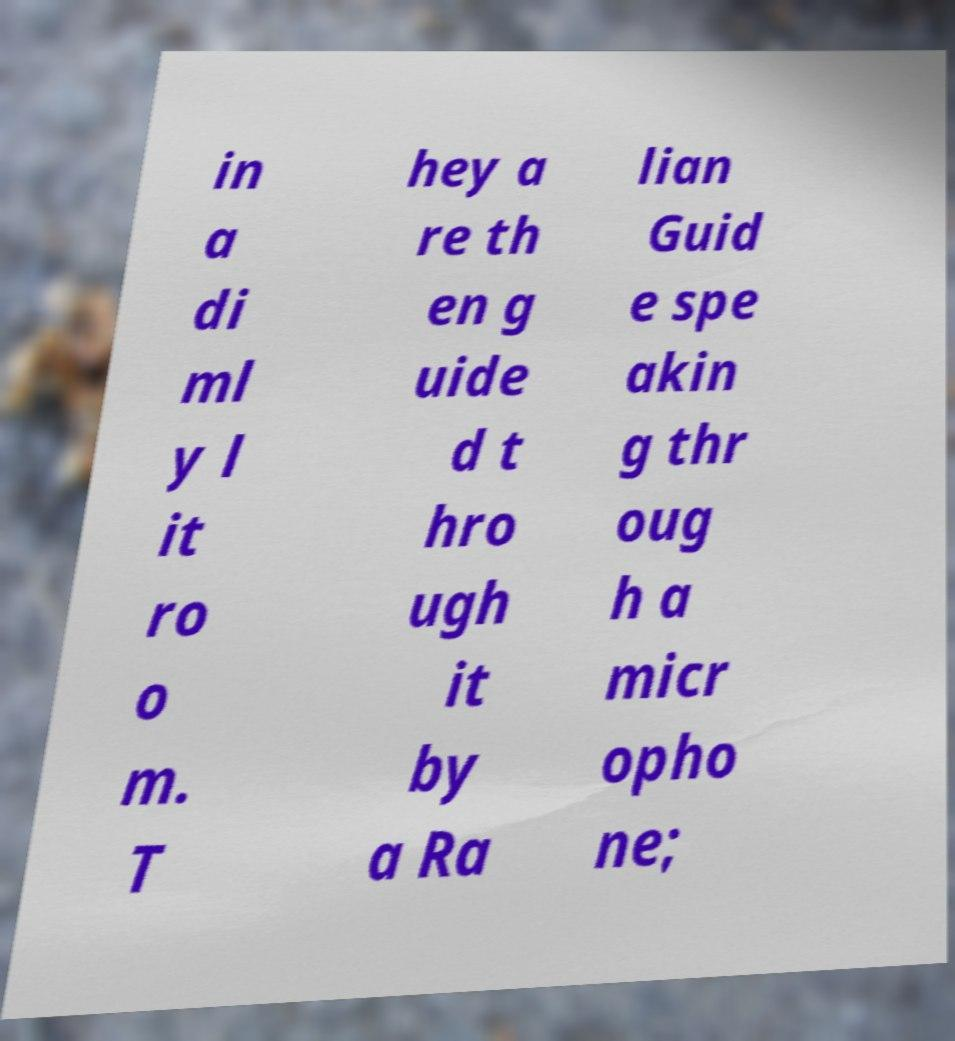Can you read and provide the text displayed in the image?This photo seems to have some interesting text. Can you extract and type it out for me? in a di ml y l it ro o m. T hey a re th en g uide d t hro ugh it by a Ra lian Guid e spe akin g thr oug h a micr opho ne; 